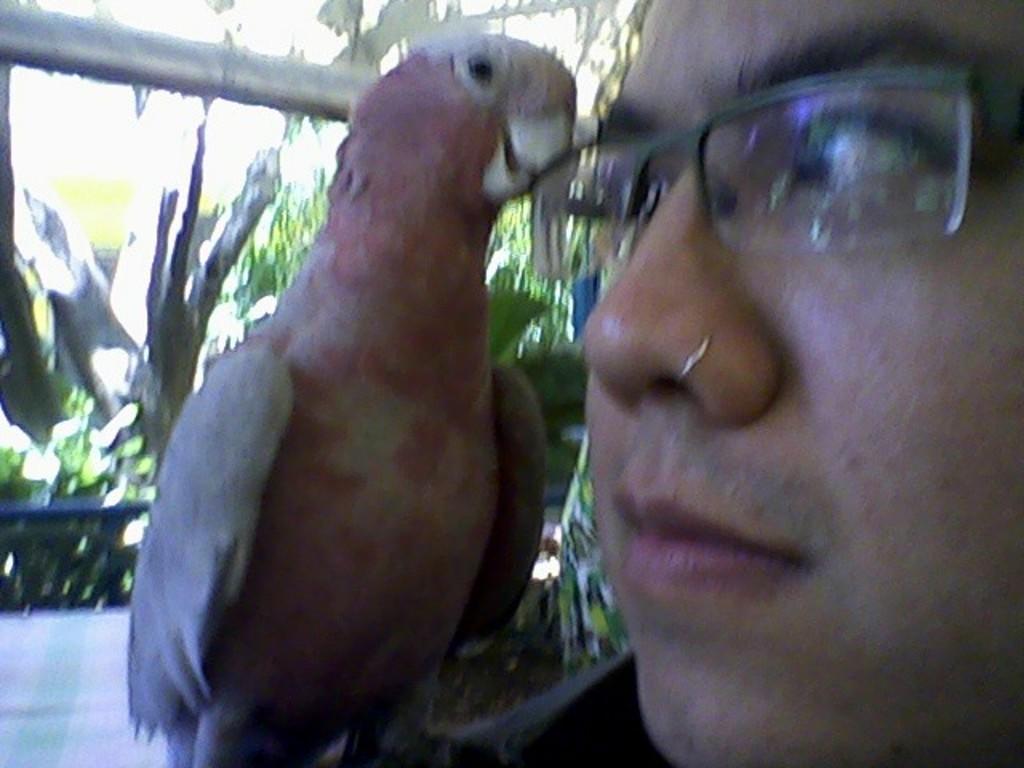In one or two sentences, can you explain what this image depicts? In this image, we can see a person wearing spectacles. We can also see a bird. We can see a rod and some plants. 